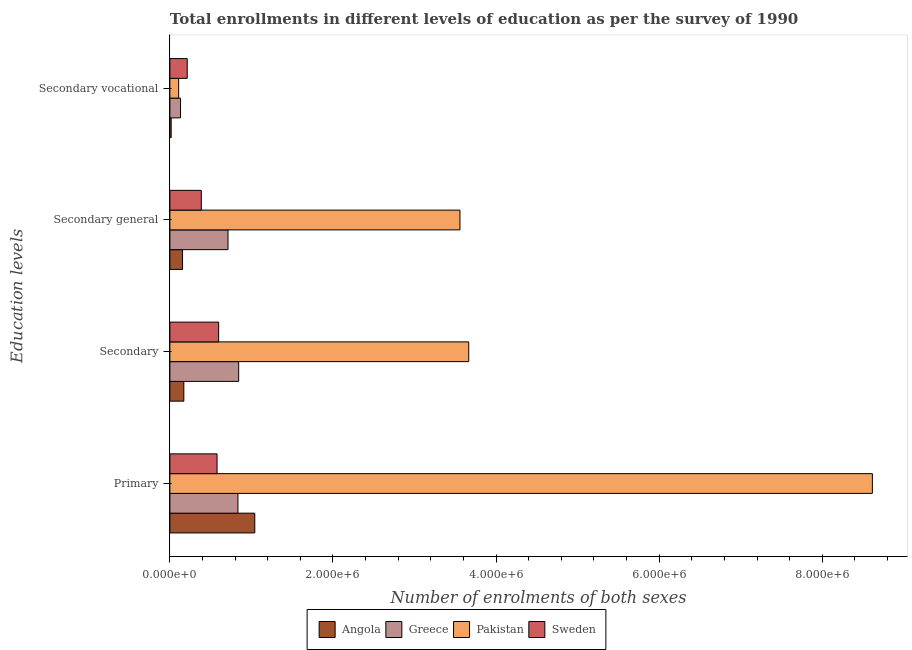How many different coloured bars are there?
Offer a very short reply. 4. How many groups of bars are there?
Keep it short and to the point. 4. How many bars are there on the 2nd tick from the top?
Your answer should be very brief. 4. How many bars are there on the 3rd tick from the bottom?
Make the answer very short. 4. What is the label of the 4th group of bars from the top?
Your answer should be compact. Primary. What is the number of enrolments in primary education in Sweden?
Your answer should be compact. 5.79e+05. Across all countries, what is the maximum number of enrolments in secondary vocational education?
Your response must be concise. 2.13e+05. Across all countries, what is the minimum number of enrolments in secondary general education?
Keep it short and to the point. 1.55e+05. In which country was the number of enrolments in secondary general education maximum?
Provide a short and direct response. Pakistan. In which country was the number of enrolments in secondary education minimum?
Keep it short and to the point. Angola. What is the total number of enrolments in primary education in the graph?
Provide a short and direct response. 1.11e+07. What is the difference between the number of enrolments in primary education in Angola and that in Pakistan?
Keep it short and to the point. -7.57e+06. What is the difference between the number of enrolments in secondary education in Sweden and the number of enrolments in secondary vocational education in Pakistan?
Make the answer very short. 4.90e+05. What is the average number of enrolments in secondary general education per country?
Your answer should be very brief. 1.20e+06. What is the difference between the number of enrolments in primary education and number of enrolments in secondary general education in Angola?
Offer a very short reply. 8.86e+05. What is the ratio of the number of enrolments in primary education in Sweden to that in Angola?
Offer a terse response. 0.56. What is the difference between the highest and the second highest number of enrolments in secondary vocational education?
Your answer should be compact. 8.20e+04. What is the difference between the highest and the lowest number of enrolments in secondary education?
Provide a succinct answer. 3.49e+06. In how many countries, is the number of enrolments in secondary education greater than the average number of enrolments in secondary education taken over all countries?
Ensure brevity in your answer.  1. What does the 2nd bar from the top in Secondary represents?
Keep it short and to the point. Pakistan. How many bars are there?
Provide a short and direct response. 16. What is the difference between two consecutive major ticks on the X-axis?
Your response must be concise. 2.00e+06. Are the values on the major ticks of X-axis written in scientific E-notation?
Your answer should be very brief. Yes. How are the legend labels stacked?
Give a very brief answer. Horizontal. What is the title of the graph?
Make the answer very short. Total enrollments in different levels of education as per the survey of 1990. Does "Brazil" appear as one of the legend labels in the graph?
Make the answer very short. No. What is the label or title of the X-axis?
Offer a very short reply. Number of enrolments of both sexes. What is the label or title of the Y-axis?
Give a very brief answer. Education levels. What is the Number of enrolments of both sexes of Angola in Primary?
Give a very brief answer. 1.04e+06. What is the Number of enrolments of both sexes in Greece in Primary?
Give a very brief answer. 8.35e+05. What is the Number of enrolments of both sexes of Pakistan in Primary?
Ensure brevity in your answer.  8.61e+06. What is the Number of enrolments of both sexes in Sweden in Primary?
Offer a very short reply. 5.79e+05. What is the Number of enrolments of both sexes in Angola in Secondary?
Provide a succinct answer. 1.71e+05. What is the Number of enrolments of both sexes in Greece in Secondary?
Keep it short and to the point. 8.44e+05. What is the Number of enrolments of both sexes of Pakistan in Secondary?
Provide a short and direct response. 3.67e+06. What is the Number of enrolments of both sexes of Sweden in Secondary?
Your response must be concise. 5.98e+05. What is the Number of enrolments of both sexes of Angola in Secondary general?
Provide a succinct answer. 1.55e+05. What is the Number of enrolments of both sexes of Greece in Secondary general?
Provide a succinct answer. 7.13e+05. What is the Number of enrolments of both sexes in Pakistan in Secondary general?
Provide a succinct answer. 3.56e+06. What is the Number of enrolments of both sexes in Sweden in Secondary general?
Give a very brief answer. 3.85e+05. What is the Number of enrolments of both sexes in Angola in Secondary vocational?
Your answer should be very brief. 1.59e+04. What is the Number of enrolments of both sexes of Greece in Secondary vocational?
Your answer should be very brief. 1.31e+05. What is the Number of enrolments of both sexes of Pakistan in Secondary vocational?
Provide a short and direct response. 1.08e+05. What is the Number of enrolments of both sexes in Sweden in Secondary vocational?
Provide a succinct answer. 2.13e+05. Across all Education levels, what is the maximum Number of enrolments of both sexes in Angola?
Provide a short and direct response. 1.04e+06. Across all Education levels, what is the maximum Number of enrolments of both sexes of Greece?
Your response must be concise. 8.44e+05. Across all Education levels, what is the maximum Number of enrolments of both sexes in Pakistan?
Your response must be concise. 8.61e+06. Across all Education levels, what is the maximum Number of enrolments of both sexes in Sweden?
Your answer should be very brief. 5.98e+05. Across all Education levels, what is the minimum Number of enrolments of both sexes of Angola?
Make the answer very short. 1.59e+04. Across all Education levels, what is the minimum Number of enrolments of both sexes in Greece?
Make the answer very short. 1.31e+05. Across all Education levels, what is the minimum Number of enrolments of both sexes of Pakistan?
Offer a terse response. 1.08e+05. Across all Education levels, what is the minimum Number of enrolments of both sexes of Sweden?
Your answer should be compact. 2.13e+05. What is the total Number of enrolments of both sexes in Angola in the graph?
Give a very brief answer. 1.38e+06. What is the total Number of enrolments of both sexes in Greece in the graph?
Your response must be concise. 2.52e+06. What is the total Number of enrolments of both sexes in Pakistan in the graph?
Your answer should be compact. 1.59e+07. What is the total Number of enrolments of both sexes in Sweden in the graph?
Give a very brief answer. 1.77e+06. What is the difference between the Number of enrolments of both sexes in Angola in Primary and that in Secondary?
Offer a very short reply. 8.70e+05. What is the difference between the Number of enrolments of both sexes in Greece in Primary and that in Secondary?
Keep it short and to the point. -9044. What is the difference between the Number of enrolments of both sexes of Pakistan in Primary and that in Secondary?
Offer a very short reply. 4.95e+06. What is the difference between the Number of enrolments of both sexes of Sweden in Primary and that in Secondary?
Your answer should be very brief. -1.94e+04. What is the difference between the Number of enrolments of both sexes in Angola in Primary and that in Secondary general?
Your response must be concise. 8.86e+05. What is the difference between the Number of enrolments of both sexes in Greece in Primary and that in Secondary general?
Make the answer very short. 1.22e+05. What is the difference between the Number of enrolments of both sexes of Pakistan in Primary and that in Secondary general?
Keep it short and to the point. 5.06e+06. What is the difference between the Number of enrolments of both sexes in Sweden in Primary and that in Secondary general?
Your answer should be compact. 1.93e+05. What is the difference between the Number of enrolments of both sexes in Angola in Primary and that in Secondary vocational?
Offer a very short reply. 1.03e+06. What is the difference between the Number of enrolments of both sexes in Greece in Primary and that in Secondary vocational?
Offer a very short reply. 7.04e+05. What is the difference between the Number of enrolments of both sexes in Pakistan in Primary and that in Secondary vocational?
Provide a short and direct response. 8.51e+06. What is the difference between the Number of enrolments of both sexes in Sweden in Primary and that in Secondary vocational?
Your answer should be very brief. 3.66e+05. What is the difference between the Number of enrolments of both sexes of Angola in Secondary and that in Secondary general?
Offer a very short reply. 1.59e+04. What is the difference between the Number of enrolments of both sexes of Greece in Secondary and that in Secondary general?
Offer a very short reply. 1.31e+05. What is the difference between the Number of enrolments of both sexes of Pakistan in Secondary and that in Secondary general?
Offer a very short reply. 1.08e+05. What is the difference between the Number of enrolments of both sexes in Sweden in Secondary and that in Secondary general?
Give a very brief answer. 2.13e+05. What is the difference between the Number of enrolments of both sexes of Angola in Secondary and that in Secondary vocational?
Make the answer very short. 1.55e+05. What is the difference between the Number of enrolments of both sexes in Greece in Secondary and that in Secondary vocational?
Give a very brief answer. 7.13e+05. What is the difference between the Number of enrolments of both sexes of Pakistan in Secondary and that in Secondary vocational?
Make the answer very short. 3.56e+06. What is the difference between the Number of enrolments of both sexes of Sweden in Secondary and that in Secondary vocational?
Ensure brevity in your answer.  3.85e+05. What is the difference between the Number of enrolments of both sexes of Angola in Secondary general and that in Secondary vocational?
Make the answer very short. 1.39e+05. What is the difference between the Number of enrolments of both sexes of Greece in Secondary general and that in Secondary vocational?
Ensure brevity in your answer.  5.82e+05. What is the difference between the Number of enrolments of both sexes in Pakistan in Secondary general and that in Secondary vocational?
Offer a terse response. 3.45e+06. What is the difference between the Number of enrolments of both sexes of Sweden in Secondary general and that in Secondary vocational?
Keep it short and to the point. 1.72e+05. What is the difference between the Number of enrolments of both sexes of Angola in Primary and the Number of enrolments of both sexes of Greece in Secondary?
Your answer should be very brief. 1.97e+05. What is the difference between the Number of enrolments of both sexes of Angola in Primary and the Number of enrolments of both sexes of Pakistan in Secondary?
Your answer should be very brief. -2.62e+06. What is the difference between the Number of enrolments of both sexes in Angola in Primary and the Number of enrolments of both sexes in Sweden in Secondary?
Offer a very short reply. 4.43e+05. What is the difference between the Number of enrolments of both sexes of Greece in Primary and the Number of enrolments of both sexes of Pakistan in Secondary?
Offer a terse response. -2.83e+06. What is the difference between the Number of enrolments of both sexes of Greece in Primary and the Number of enrolments of both sexes of Sweden in Secondary?
Keep it short and to the point. 2.37e+05. What is the difference between the Number of enrolments of both sexes in Pakistan in Primary and the Number of enrolments of both sexes in Sweden in Secondary?
Give a very brief answer. 8.02e+06. What is the difference between the Number of enrolments of both sexes of Angola in Primary and the Number of enrolments of both sexes of Greece in Secondary general?
Provide a short and direct response. 3.28e+05. What is the difference between the Number of enrolments of both sexes of Angola in Primary and the Number of enrolments of both sexes of Pakistan in Secondary general?
Offer a terse response. -2.52e+06. What is the difference between the Number of enrolments of both sexes in Angola in Primary and the Number of enrolments of both sexes in Sweden in Secondary general?
Provide a short and direct response. 6.56e+05. What is the difference between the Number of enrolments of both sexes of Greece in Primary and the Number of enrolments of both sexes of Pakistan in Secondary general?
Offer a very short reply. -2.72e+06. What is the difference between the Number of enrolments of both sexes in Greece in Primary and the Number of enrolments of both sexes in Sweden in Secondary general?
Your response must be concise. 4.49e+05. What is the difference between the Number of enrolments of both sexes in Pakistan in Primary and the Number of enrolments of both sexes in Sweden in Secondary general?
Your answer should be compact. 8.23e+06. What is the difference between the Number of enrolments of both sexes of Angola in Primary and the Number of enrolments of both sexes of Greece in Secondary vocational?
Your answer should be compact. 9.10e+05. What is the difference between the Number of enrolments of both sexes of Angola in Primary and the Number of enrolments of both sexes of Pakistan in Secondary vocational?
Keep it short and to the point. 9.33e+05. What is the difference between the Number of enrolments of both sexes in Angola in Primary and the Number of enrolments of both sexes in Sweden in Secondary vocational?
Your answer should be very brief. 8.28e+05. What is the difference between the Number of enrolments of both sexes of Greece in Primary and the Number of enrolments of both sexes of Pakistan in Secondary vocational?
Your response must be concise. 7.27e+05. What is the difference between the Number of enrolments of both sexes in Greece in Primary and the Number of enrolments of both sexes in Sweden in Secondary vocational?
Offer a terse response. 6.22e+05. What is the difference between the Number of enrolments of both sexes in Pakistan in Primary and the Number of enrolments of both sexes in Sweden in Secondary vocational?
Your answer should be very brief. 8.40e+06. What is the difference between the Number of enrolments of both sexes in Angola in Secondary and the Number of enrolments of both sexes in Greece in Secondary general?
Offer a very short reply. -5.42e+05. What is the difference between the Number of enrolments of both sexes of Angola in Secondary and the Number of enrolments of both sexes of Pakistan in Secondary general?
Your answer should be compact. -3.39e+06. What is the difference between the Number of enrolments of both sexes in Angola in Secondary and the Number of enrolments of both sexes in Sweden in Secondary general?
Give a very brief answer. -2.14e+05. What is the difference between the Number of enrolments of both sexes in Greece in Secondary and the Number of enrolments of both sexes in Pakistan in Secondary general?
Keep it short and to the point. -2.71e+06. What is the difference between the Number of enrolments of both sexes of Greece in Secondary and the Number of enrolments of both sexes of Sweden in Secondary general?
Provide a short and direct response. 4.58e+05. What is the difference between the Number of enrolments of both sexes of Pakistan in Secondary and the Number of enrolments of both sexes of Sweden in Secondary general?
Keep it short and to the point. 3.28e+06. What is the difference between the Number of enrolments of both sexes of Angola in Secondary and the Number of enrolments of both sexes of Greece in Secondary vocational?
Provide a short and direct response. 4.04e+04. What is the difference between the Number of enrolments of both sexes in Angola in Secondary and the Number of enrolments of both sexes in Pakistan in Secondary vocational?
Offer a terse response. 6.35e+04. What is the difference between the Number of enrolments of both sexes of Angola in Secondary and the Number of enrolments of both sexes of Sweden in Secondary vocational?
Make the answer very short. -4.16e+04. What is the difference between the Number of enrolments of both sexes of Greece in Secondary and the Number of enrolments of both sexes of Pakistan in Secondary vocational?
Provide a succinct answer. 7.36e+05. What is the difference between the Number of enrolments of both sexes of Greece in Secondary and the Number of enrolments of both sexes of Sweden in Secondary vocational?
Give a very brief answer. 6.31e+05. What is the difference between the Number of enrolments of both sexes in Pakistan in Secondary and the Number of enrolments of both sexes in Sweden in Secondary vocational?
Your response must be concise. 3.45e+06. What is the difference between the Number of enrolments of both sexes of Angola in Secondary general and the Number of enrolments of both sexes of Greece in Secondary vocational?
Keep it short and to the point. 2.45e+04. What is the difference between the Number of enrolments of both sexes of Angola in Secondary general and the Number of enrolments of both sexes of Pakistan in Secondary vocational?
Your answer should be compact. 4.76e+04. What is the difference between the Number of enrolments of both sexes of Angola in Secondary general and the Number of enrolments of both sexes of Sweden in Secondary vocational?
Provide a short and direct response. -5.75e+04. What is the difference between the Number of enrolments of both sexes of Greece in Secondary general and the Number of enrolments of both sexes of Pakistan in Secondary vocational?
Offer a very short reply. 6.05e+05. What is the difference between the Number of enrolments of both sexes of Greece in Secondary general and the Number of enrolments of both sexes of Sweden in Secondary vocational?
Offer a terse response. 5.00e+05. What is the difference between the Number of enrolments of both sexes of Pakistan in Secondary general and the Number of enrolments of both sexes of Sweden in Secondary vocational?
Ensure brevity in your answer.  3.34e+06. What is the average Number of enrolments of both sexes of Angola per Education levels?
Provide a succinct answer. 3.46e+05. What is the average Number of enrolments of both sexes in Greece per Education levels?
Ensure brevity in your answer.  6.31e+05. What is the average Number of enrolments of both sexes in Pakistan per Education levels?
Provide a short and direct response. 3.99e+06. What is the average Number of enrolments of both sexes in Sweden per Education levels?
Ensure brevity in your answer.  4.44e+05. What is the difference between the Number of enrolments of both sexes of Angola and Number of enrolments of both sexes of Greece in Primary?
Your response must be concise. 2.06e+05. What is the difference between the Number of enrolments of both sexes of Angola and Number of enrolments of both sexes of Pakistan in Primary?
Give a very brief answer. -7.57e+06. What is the difference between the Number of enrolments of both sexes of Angola and Number of enrolments of both sexes of Sweden in Primary?
Your response must be concise. 4.63e+05. What is the difference between the Number of enrolments of both sexes in Greece and Number of enrolments of both sexes in Pakistan in Primary?
Ensure brevity in your answer.  -7.78e+06. What is the difference between the Number of enrolments of both sexes of Greece and Number of enrolments of both sexes of Sweden in Primary?
Your response must be concise. 2.56e+05. What is the difference between the Number of enrolments of both sexes of Pakistan and Number of enrolments of both sexes of Sweden in Primary?
Make the answer very short. 8.04e+06. What is the difference between the Number of enrolments of both sexes of Angola and Number of enrolments of both sexes of Greece in Secondary?
Your answer should be compact. -6.73e+05. What is the difference between the Number of enrolments of both sexes of Angola and Number of enrolments of both sexes of Pakistan in Secondary?
Keep it short and to the point. -3.49e+06. What is the difference between the Number of enrolments of both sexes of Angola and Number of enrolments of both sexes of Sweden in Secondary?
Make the answer very short. -4.27e+05. What is the difference between the Number of enrolments of both sexes of Greece and Number of enrolments of both sexes of Pakistan in Secondary?
Make the answer very short. -2.82e+06. What is the difference between the Number of enrolments of both sexes in Greece and Number of enrolments of both sexes in Sweden in Secondary?
Your answer should be compact. 2.46e+05. What is the difference between the Number of enrolments of both sexes in Pakistan and Number of enrolments of both sexes in Sweden in Secondary?
Offer a very short reply. 3.07e+06. What is the difference between the Number of enrolments of both sexes of Angola and Number of enrolments of both sexes of Greece in Secondary general?
Provide a succinct answer. -5.58e+05. What is the difference between the Number of enrolments of both sexes in Angola and Number of enrolments of both sexes in Pakistan in Secondary general?
Give a very brief answer. -3.40e+06. What is the difference between the Number of enrolments of both sexes in Angola and Number of enrolments of both sexes in Sweden in Secondary general?
Your answer should be very brief. -2.30e+05. What is the difference between the Number of enrolments of both sexes of Greece and Number of enrolments of both sexes of Pakistan in Secondary general?
Offer a terse response. -2.84e+06. What is the difference between the Number of enrolments of both sexes in Greece and Number of enrolments of both sexes in Sweden in Secondary general?
Your answer should be very brief. 3.28e+05. What is the difference between the Number of enrolments of both sexes in Pakistan and Number of enrolments of both sexes in Sweden in Secondary general?
Give a very brief answer. 3.17e+06. What is the difference between the Number of enrolments of both sexes of Angola and Number of enrolments of both sexes of Greece in Secondary vocational?
Your answer should be very brief. -1.15e+05. What is the difference between the Number of enrolments of both sexes in Angola and Number of enrolments of both sexes in Pakistan in Secondary vocational?
Provide a succinct answer. -9.17e+04. What is the difference between the Number of enrolments of both sexes in Angola and Number of enrolments of both sexes in Sweden in Secondary vocational?
Provide a succinct answer. -1.97e+05. What is the difference between the Number of enrolments of both sexes of Greece and Number of enrolments of both sexes of Pakistan in Secondary vocational?
Provide a succinct answer. 2.31e+04. What is the difference between the Number of enrolments of both sexes in Greece and Number of enrolments of both sexes in Sweden in Secondary vocational?
Keep it short and to the point. -8.20e+04. What is the difference between the Number of enrolments of both sexes in Pakistan and Number of enrolments of both sexes in Sweden in Secondary vocational?
Give a very brief answer. -1.05e+05. What is the ratio of the Number of enrolments of both sexes of Angola in Primary to that in Secondary?
Offer a very short reply. 6.08. What is the ratio of the Number of enrolments of both sexes in Greece in Primary to that in Secondary?
Your response must be concise. 0.99. What is the ratio of the Number of enrolments of both sexes of Pakistan in Primary to that in Secondary?
Your response must be concise. 2.35. What is the ratio of the Number of enrolments of both sexes in Sweden in Primary to that in Secondary?
Ensure brevity in your answer.  0.97. What is the ratio of the Number of enrolments of both sexes of Angola in Primary to that in Secondary general?
Give a very brief answer. 6.71. What is the ratio of the Number of enrolments of both sexes in Greece in Primary to that in Secondary general?
Keep it short and to the point. 1.17. What is the ratio of the Number of enrolments of both sexes in Pakistan in Primary to that in Secondary general?
Your answer should be compact. 2.42. What is the ratio of the Number of enrolments of both sexes of Sweden in Primary to that in Secondary general?
Give a very brief answer. 1.5. What is the ratio of the Number of enrolments of both sexes of Angola in Primary to that in Secondary vocational?
Keep it short and to the point. 65.48. What is the ratio of the Number of enrolments of both sexes of Greece in Primary to that in Secondary vocational?
Ensure brevity in your answer.  6.38. What is the ratio of the Number of enrolments of both sexes in Pakistan in Primary to that in Secondary vocational?
Make the answer very short. 80.03. What is the ratio of the Number of enrolments of both sexes of Sweden in Primary to that in Secondary vocational?
Provide a succinct answer. 2.72. What is the ratio of the Number of enrolments of both sexes of Angola in Secondary to that in Secondary general?
Ensure brevity in your answer.  1.1. What is the ratio of the Number of enrolments of both sexes in Greece in Secondary to that in Secondary general?
Ensure brevity in your answer.  1.18. What is the ratio of the Number of enrolments of both sexes in Pakistan in Secondary to that in Secondary general?
Offer a terse response. 1.03. What is the ratio of the Number of enrolments of both sexes in Sweden in Secondary to that in Secondary general?
Provide a succinct answer. 1.55. What is the ratio of the Number of enrolments of both sexes in Angola in Secondary to that in Secondary vocational?
Provide a succinct answer. 10.77. What is the ratio of the Number of enrolments of both sexes of Greece in Secondary to that in Secondary vocational?
Your answer should be compact. 6.45. What is the ratio of the Number of enrolments of both sexes of Pakistan in Secondary to that in Secondary vocational?
Ensure brevity in your answer.  34.05. What is the ratio of the Number of enrolments of both sexes in Sweden in Secondary to that in Secondary vocational?
Your response must be concise. 2.81. What is the ratio of the Number of enrolments of both sexes in Angola in Secondary general to that in Secondary vocational?
Give a very brief answer. 9.77. What is the ratio of the Number of enrolments of both sexes in Greece in Secondary general to that in Secondary vocational?
Make the answer very short. 5.45. What is the ratio of the Number of enrolments of both sexes of Pakistan in Secondary general to that in Secondary vocational?
Your response must be concise. 33.05. What is the ratio of the Number of enrolments of both sexes of Sweden in Secondary general to that in Secondary vocational?
Provide a succinct answer. 1.81. What is the difference between the highest and the second highest Number of enrolments of both sexes in Angola?
Give a very brief answer. 8.70e+05. What is the difference between the highest and the second highest Number of enrolments of both sexes in Greece?
Provide a succinct answer. 9044. What is the difference between the highest and the second highest Number of enrolments of both sexes in Pakistan?
Give a very brief answer. 4.95e+06. What is the difference between the highest and the second highest Number of enrolments of both sexes of Sweden?
Keep it short and to the point. 1.94e+04. What is the difference between the highest and the lowest Number of enrolments of both sexes of Angola?
Keep it short and to the point. 1.03e+06. What is the difference between the highest and the lowest Number of enrolments of both sexes in Greece?
Your answer should be compact. 7.13e+05. What is the difference between the highest and the lowest Number of enrolments of both sexes in Pakistan?
Ensure brevity in your answer.  8.51e+06. What is the difference between the highest and the lowest Number of enrolments of both sexes of Sweden?
Keep it short and to the point. 3.85e+05. 